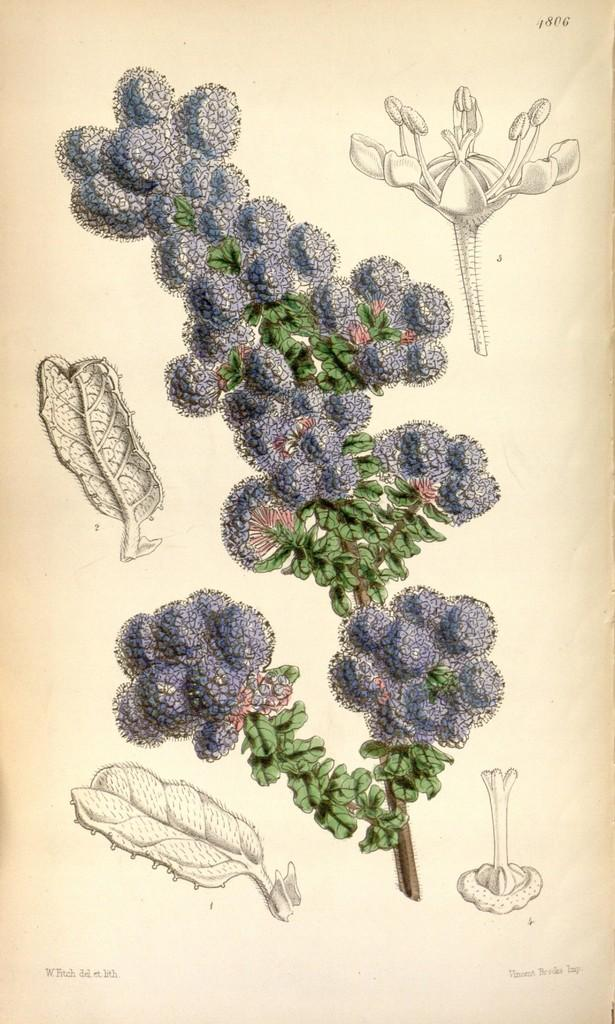What is depicted on the paper in the image? There are drawings and text on a paper in the image. Can you describe the drawings on the paper? Unfortunately, the details of the drawings cannot be determined from the image alone. What type of text is present on the paper? The specific content of the text cannot be determined from the image alone. What type of jelly is being used to answer the questions on the paper? There is no jelly present in the image, and the text on the paper is not being answered using jelly. 